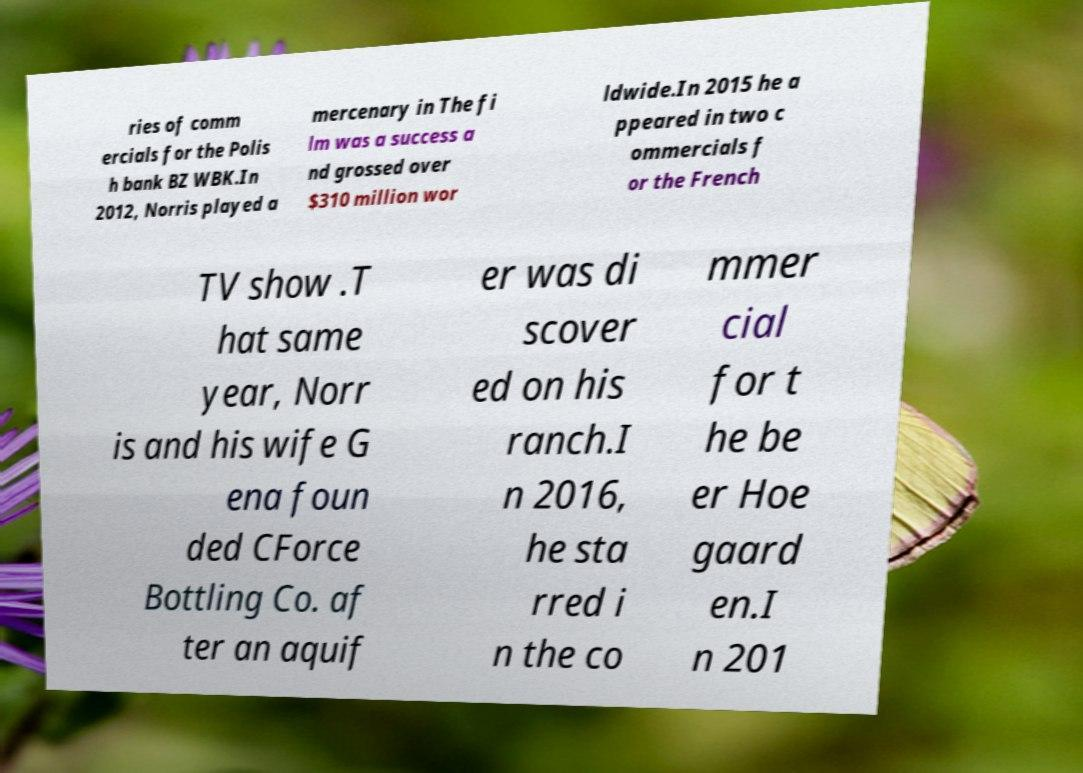Could you extract and type out the text from this image? ries of comm ercials for the Polis h bank BZ WBK.In 2012, Norris played a mercenary in The fi lm was a success a nd grossed over $310 million wor ldwide.In 2015 he a ppeared in two c ommercials f or the French TV show .T hat same year, Norr is and his wife G ena foun ded CForce Bottling Co. af ter an aquif er was di scover ed on his ranch.I n 2016, he sta rred i n the co mmer cial for t he be er Hoe gaard en.I n 201 